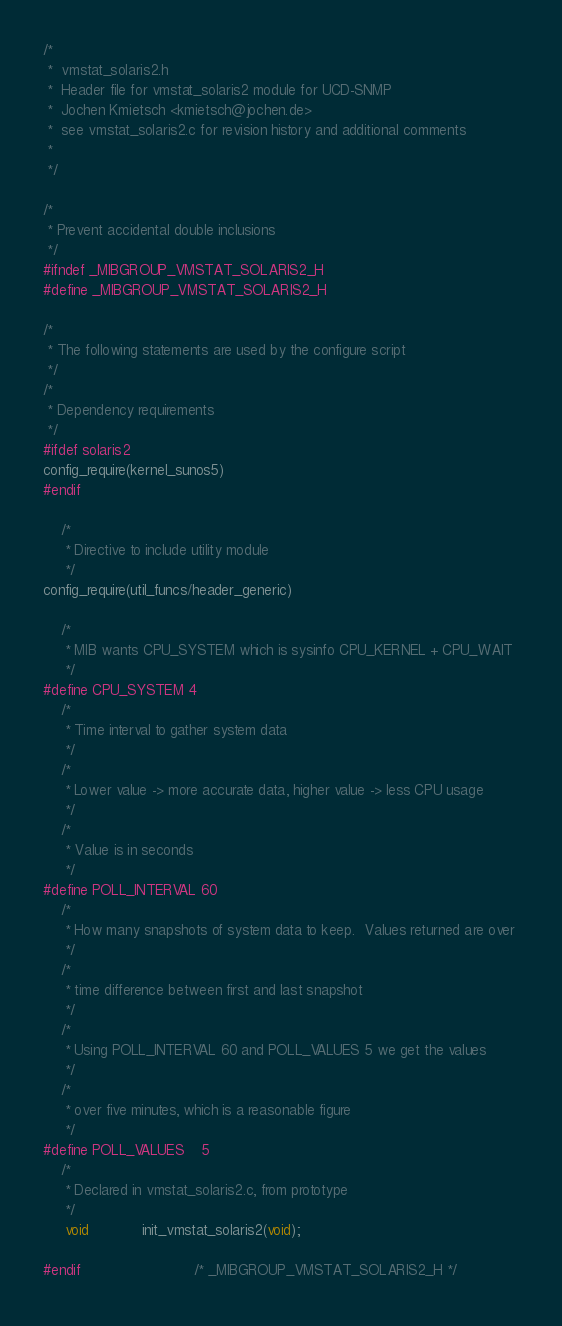Convert code to text. <code><loc_0><loc_0><loc_500><loc_500><_C_>/*
 *  vmstat_solaris2.h
 *  Header file for vmstat_solaris2 module for UCD-SNMP
 *  Jochen Kmietsch <kmietsch@jochen.de>
 *  see vmstat_solaris2.c for revision history and additional comments
 *
 */

/*
 * Prevent accidental double inclusions 
 */
#ifndef _MIBGROUP_VMSTAT_SOLARIS2_H
#define _MIBGROUP_VMSTAT_SOLARIS2_H

/*
 * The following statements are used by the configure script 
 */
/*
 * Dependency requirements 
 */
#ifdef solaris2
config_require(kernel_sunos5)
#endif

    /*
     * Directive to include utility module 
     */
config_require(util_funcs/header_generic)

    /*
     * MIB wants CPU_SYSTEM which is sysinfo CPU_KERNEL + CPU_WAIT 
     */
#define CPU_SYSTEM 4
    /*
     * Time interval to gather system data 
     */
    /*
     * Lower value -> more accurate data, higher value -> less CPU usage 
     */
    /*
     * Value is in seconds 
     */
#define POLL_INTERVAL 60
    /*
     * How many snapshots of system data to keep.  Values returned are over 
     */
    /*
     * time difference between first and last snapshot 
     */
    /*
     * Using POLL_INTERVAL 60 and POLL_VALUES 5 we get the values 
     */
    /*
     * over five minutes, which is a reasonable figure 
     */
#define POLL_VALUES    5
    /*
     * Declared in vmstat_solaris2.c, from prototype 
     */
     void            init_vmstat_solaris2(void);

#endif                          /* _MIBGROUP_VMSTAT_SOLARIS2_H */
</code> 